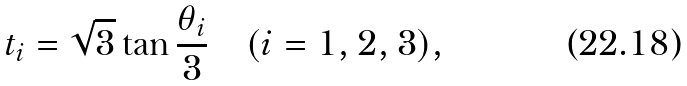<formula> <loc_0><loc_0><loc_500><loc_500>t _ { i } = \sqrt { 3 } \tan \frac { \theta _ { i } } { 3 } \quad ( i = 1 , 2 , 3 ) ,</formula> 